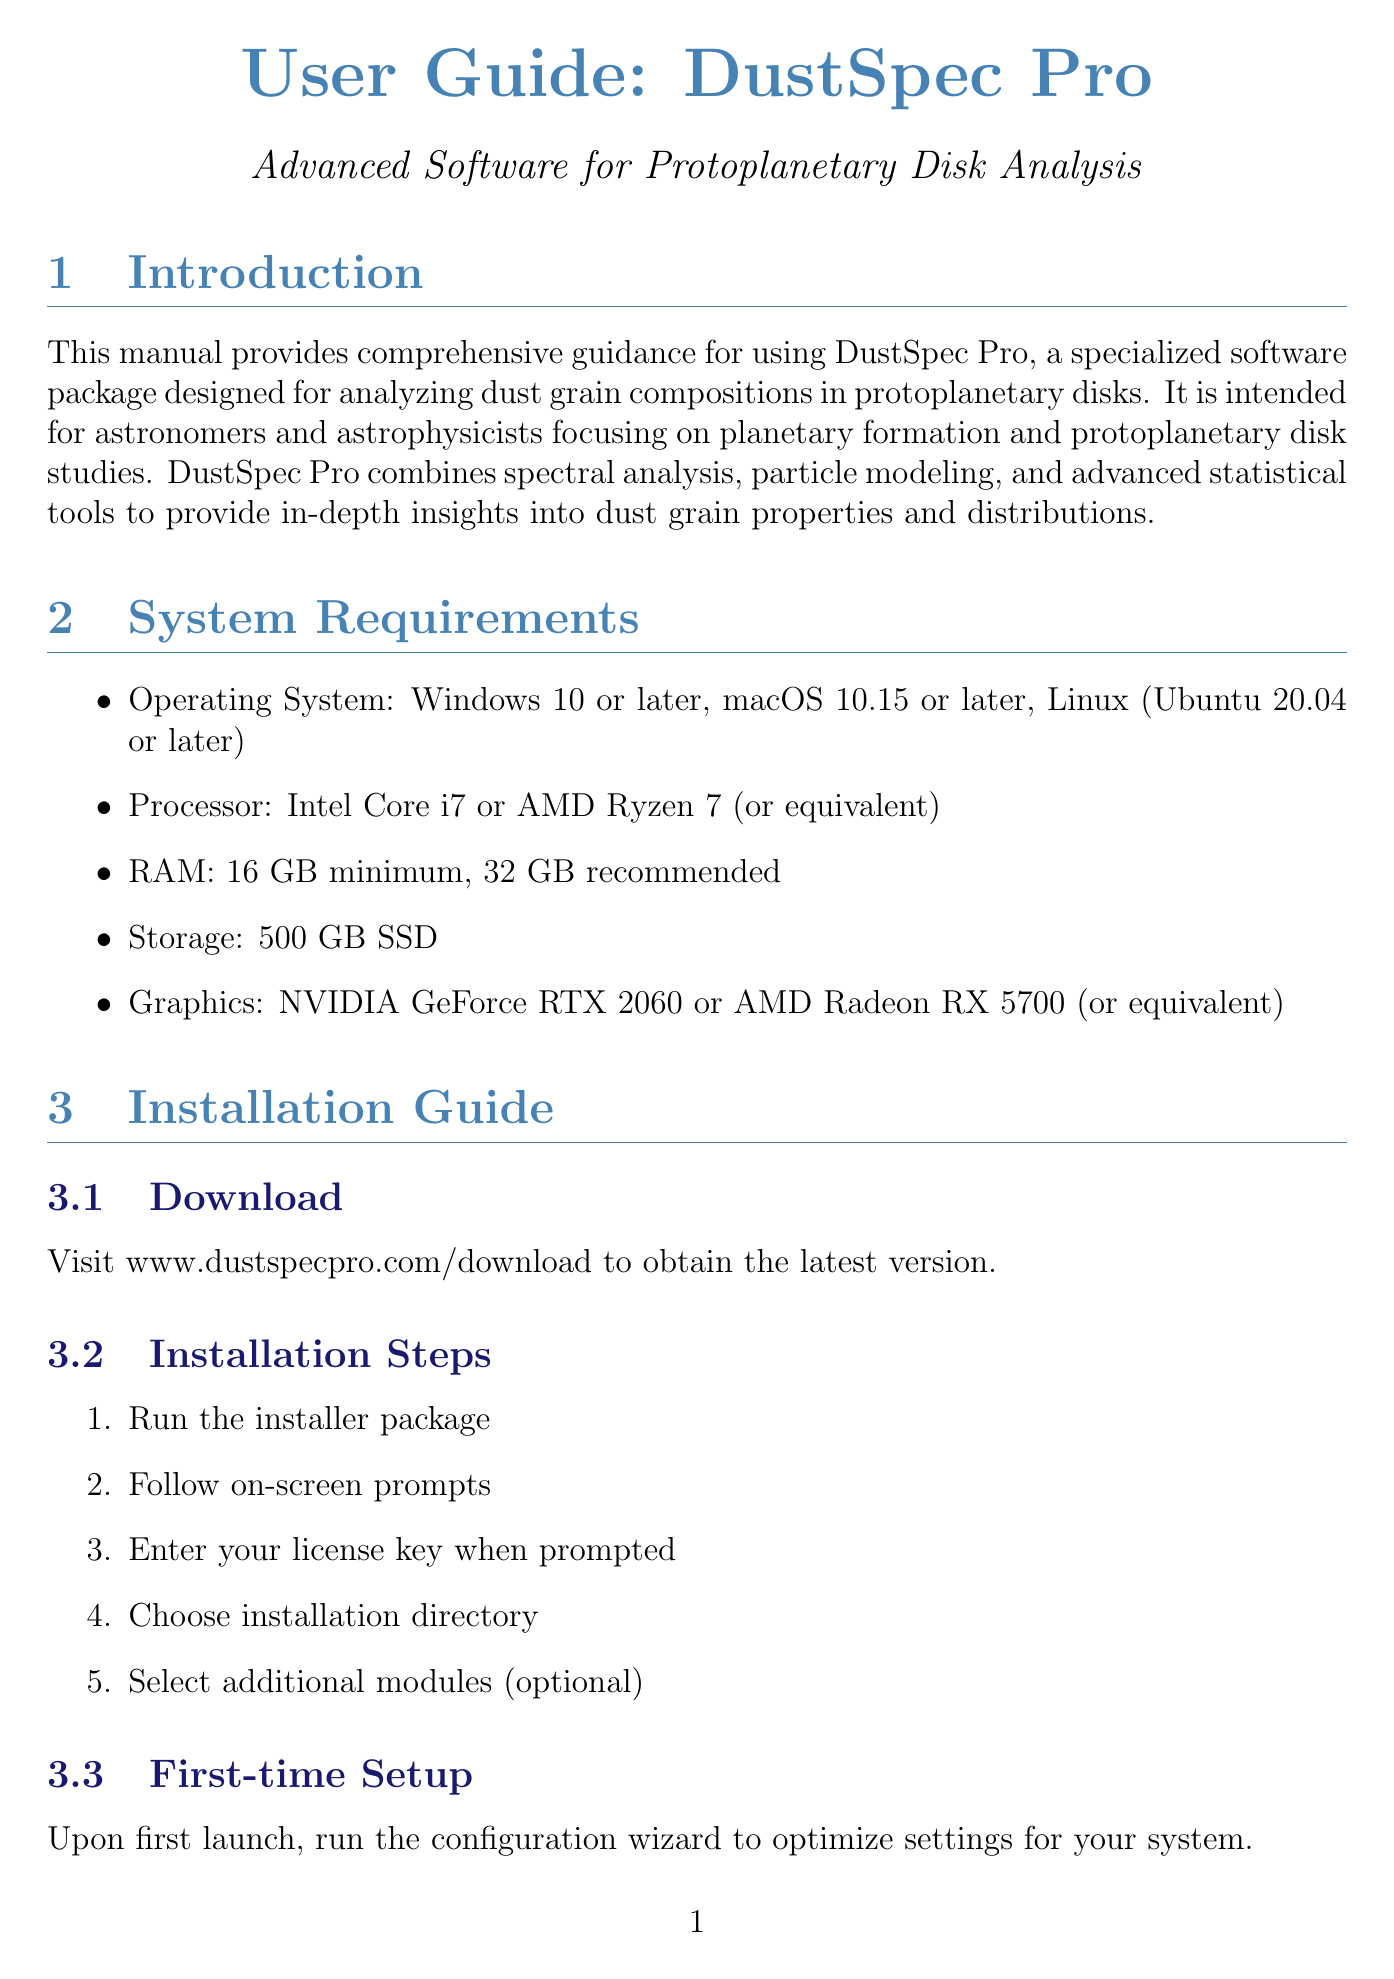What is the manual titled? The title of the manual, as stated in the document, is about the DustSpec Pro software for protoplanetary disk analysis.
Answer: User Guide: DustSpec Pro - Advanced Software for Protoplanetary Disk Analysis What is the minimum RAM requirement? The document specifies the minimum RAM requirement for running the software.
Answer: 16 GB minimum Which operating system is not supported? The supported operating systems are listed, indicating which systems are not compatible with the software.
Answer: Older versions of Windows What type of error analysis technique does the software include? The document mentions specific error estimation techniques that the software utilizes.
Answer: Monte Carlo method What is one key function of the Spectral Analysis Module? The document outlines key functions related to the Spectral Analysis Module for processing spectral data.
Answer: Data import from multiple file formats What feature would you examine to identify grain growth in the disks? The document discusses features to analyze for evolutionary indicators related to grain growth.
Answer: Grain growth signatures What should be checked if there are errors in data import? The document provides advice on troubleshooting common issues related to the software's operation.
Answer: Data format compatibility In which section can you find the procedure for installing the software? The document is organized into sections, each dealing with different aspects of the software, including installation procedures.
Answer: Installation Guide 